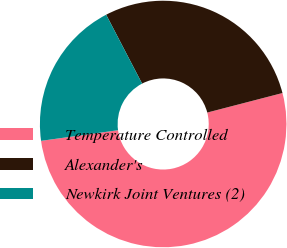Convert chart. <chart><loc_0><loc_0><loc_500><loc_500><pie_chart><fcel>Temperature Controlled<fcel>Alexander's<fcel>Newkirk Joint Ventures (2)<nl><fcel>51.86%<fcel>28.61%<fcel>19.53%<nl></chart> 